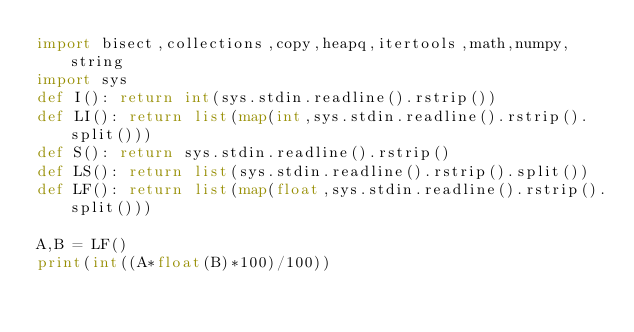<code> <loc_0><loc_0><loc_500><loc_500><_Python_>import bisect,collections,copy,heapq,itertools,math,numpy,string
import sys
def I(): return int(sys.stdin.readline().rstrip())
def LI(): return list(map(int,sys.stdin.readline().rstrip().split()))
def S(): return sys.stdin.readline().rstrip()
def LS(): return list(sys.stdin.readline().rstrip().split())
def LF(): return list(map(float,sys.stdin.readline().rstrip().split()))

A,B = LF()
print(int((A*float(B)*100)/100))</code> 